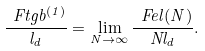Convert formula to latex. <formula><loc_0><loc_0><loc_500><loc_500>\frac { \ F t g b ^ { ( 1 ) } } { l _ { d } } = \lim _ { N \to \infty } \frac { \ F e l ( N ) } { N l _ { d } } .</formula> 